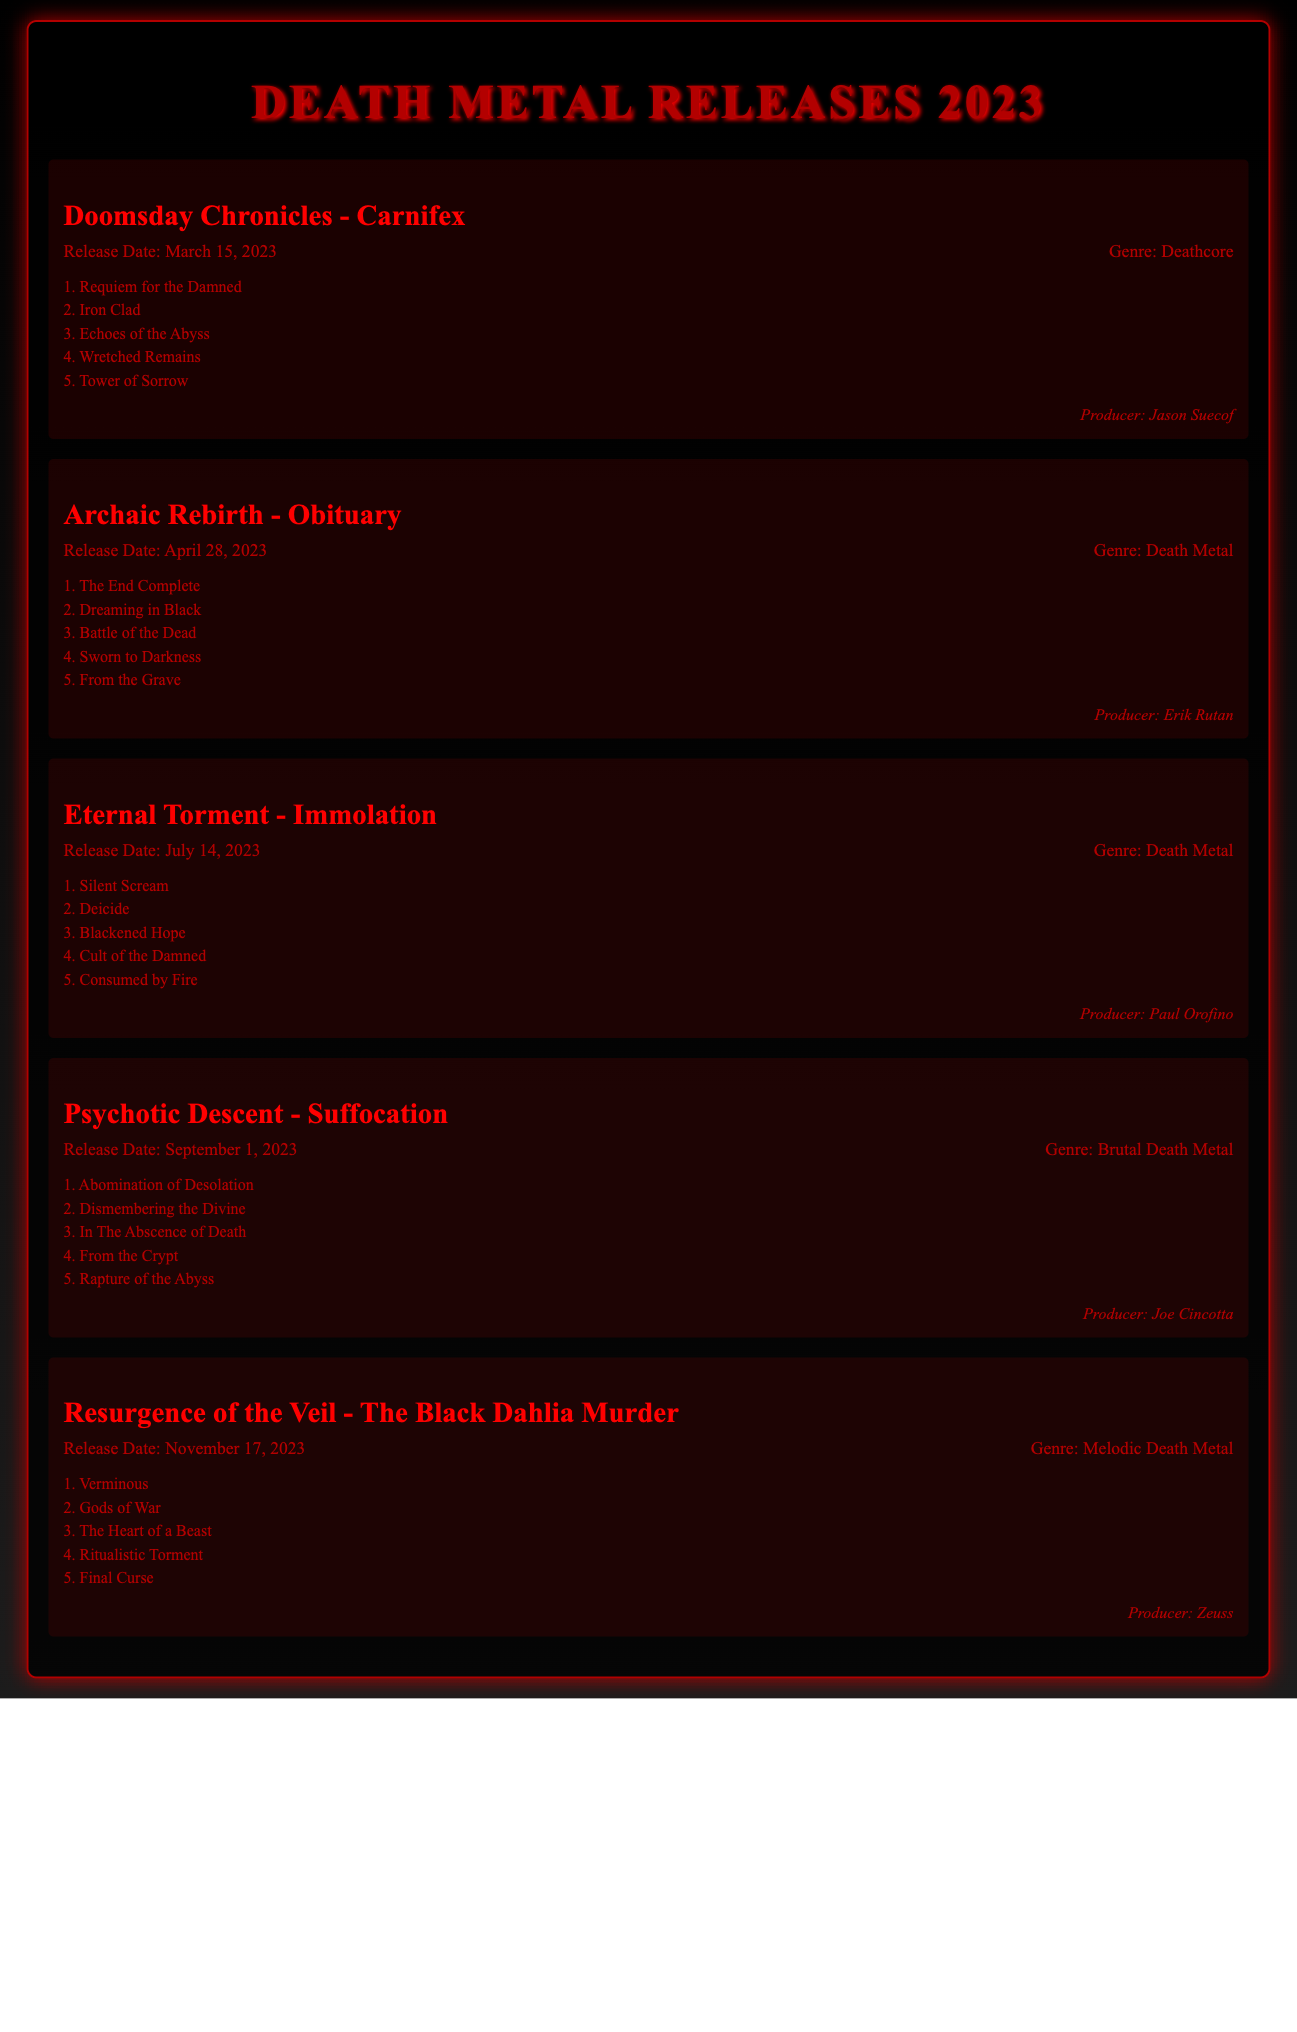What is the title of the album by Carnifex? The title is listed in the document under their section, which is "Doomsday Chronicles."
Answer: Doomsday Chronicles When was "Archaic Rebirth" released? The release date for "Archaic Rebirth" can be found in the album info section, which states April 28, 2023.
Answer: April 28, 2023 Who produced "Eternal Torment"? The document provides producer information for each album; "Eternal Torment" was produced by Paul Orofino.
Answer: Paul Orofino What genre is "Psychotic Descent"? The genre is mentioned in the album info section, indicating it is "Brutal Death Metal."
Answer: Brutal Death Metal How many tracks are listed for "Resurgence of the Veil"? The number of tracks can be counted from the track list provided for "Resurgence of the Veil," which contains five tracks.
Answer: 5 Which album has the release date of March 15, 2023? The album info section lists the release date for "Doomsday Chronicles" as March 15, 2023.
Answer: Doomsday Chronicles What is the third track of "Eternal Torment"? The track list for "Eternal Torment" contains the track titles, with the third track being "Blackened Hope."
Answer: Blackened Hope Who is the artist for "The Black Dahlia Murder"? The document clearly identifies the artist for the album titled "Resurgence of the Veil" as The Black Dahlia Murder.
Answer: The Black Dahlia Murder 